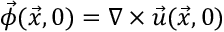Convert formula to latex. <formula><loc_0><loc_0><loc_500><loc_500>\vec { \phi } ( \vec { x } , 0 ) = \nabla \times \vec { u } ( \vec { x } , 0 )</formula> 